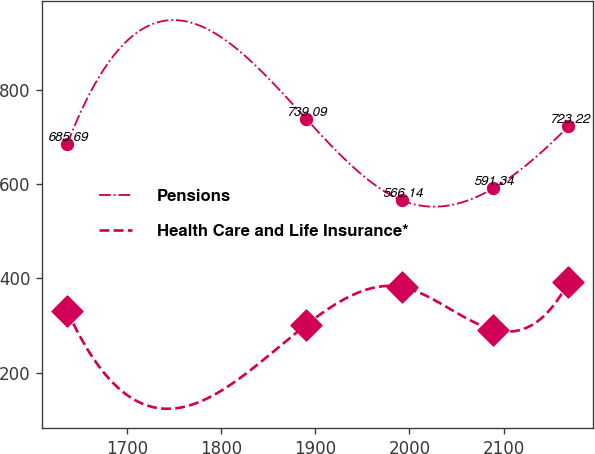<chart> <loc_0><loc_0><loc_500><loc_500><line_chart><ecel><fcel>Pensions<fcel>Health Care and Life Insurance*<nl><fcel>1636.79<fcel>685.69<fcel>330.98<nl><fcel>1890.45<fcel>739.09<fcel>301.24<nl><fcel>1991.74<fcel>566.14<fcel>381.86<nl><fcel>2089<fcel>591.34<fcel>291.39<nl><fcel>2168.84<fcel>723.22<fcel>391.71<nl></chart> 